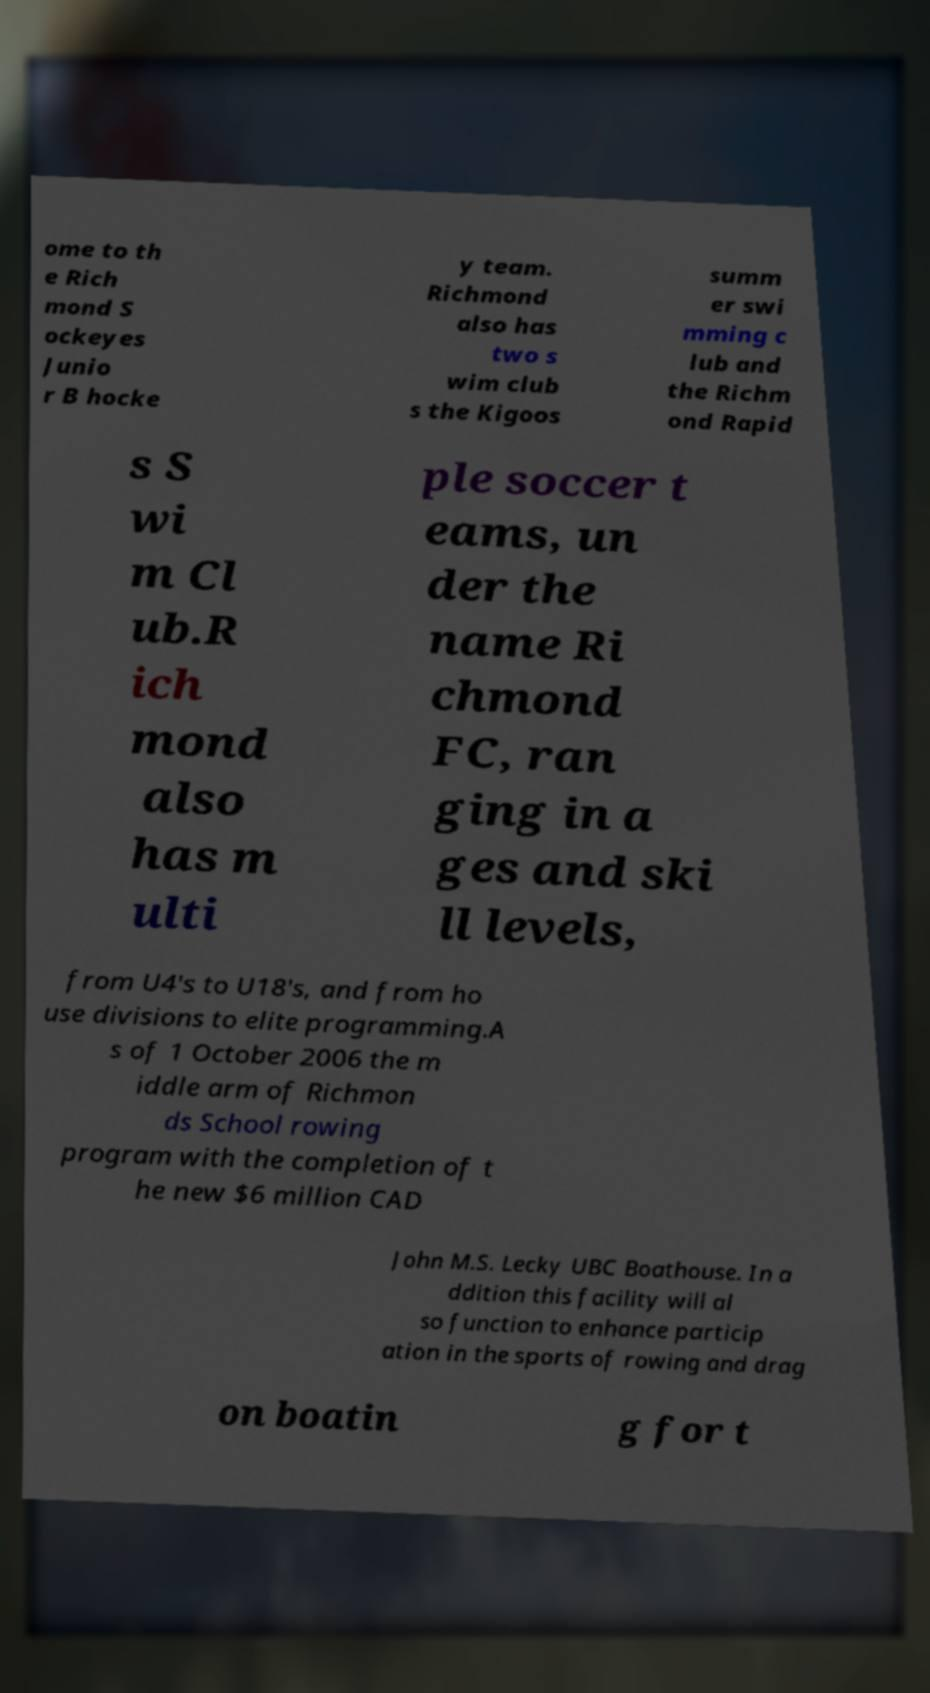Can you accurately transcribe the text from the provided image for me? ome to th e Rich mond S ockeyes Junio r B hocke y team. Richmond also has two s wim club s the Kigoos summ er swi mming c lub and the Richm ond Rapid s S wi m Cl ub.R ich mond also has m ulti ple soccer t eams, un der the name Ri chmond FC, ran ging in a ges and ski ll levels, from U4's to U18's, and from ho use divisions to elite programming.A s of 1 October 2006 the m iddle arm of Richmon ds School rowing program with the completion of t he new $6 million CAD John M.S. Lecky UBC Boathouse. In a ddition this facility will al so function to enhance particip ation in the sports of rowing and drag on boatin g for t 